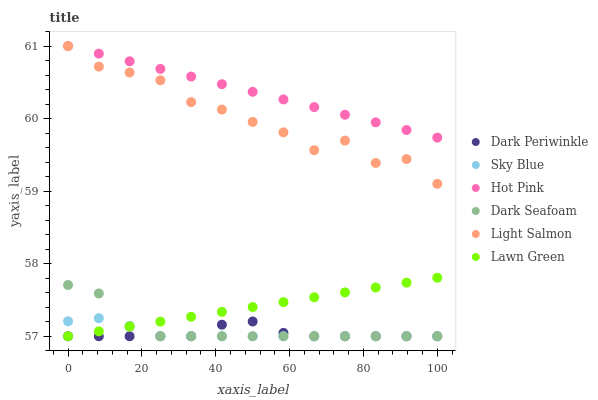Does Dark Periwinkle have the minimum area under the curve?
Answer yes or no. Yes. Does Hot Pink have the maximum area under the curve?
Answer yes or no. Yes. Does Light Salmon have the minimum area under the curve?
Answer yes or no. No. Does Light Salmon have the maximum area under the curve?
Answer yes or no. No. Is Lawn Green the smoothest?
Answer yes or no. Yes. Is Light Salmon the roughest?
Answer yes or no. Yes. Is Hot Pink the smoothest?
Answer yes or no. No. Is Hot Pink the roughest?
Answer yes or no. No. Does Lawn Green have the lowest value?
Answer yes or no. Yes. Does Light Salmon have the lowest value?
Answer yes or no. No. Does Hot Pink have the highest value?
Answer yes or no. Yes. Does Dark Seafoam have the highest value?
Answer yes or no. No. Is Dark Periwinkle less than Light Salmon?
Answer yes or no. Yes. Is Hot Pink greater than Sky Blue?
Answer yes or no. Yes. Does Sky Blue intersect Lawn Green?
Answer yes or no. Yes. Is Sky Blue less than Lawn Green?
Answer yes or no. No. Is Sky Blue greater than Lawn Green?
Answer yes or no. No. Does Dark Periwinkle intersect Light Salmon?
Answer yes or no. No. 